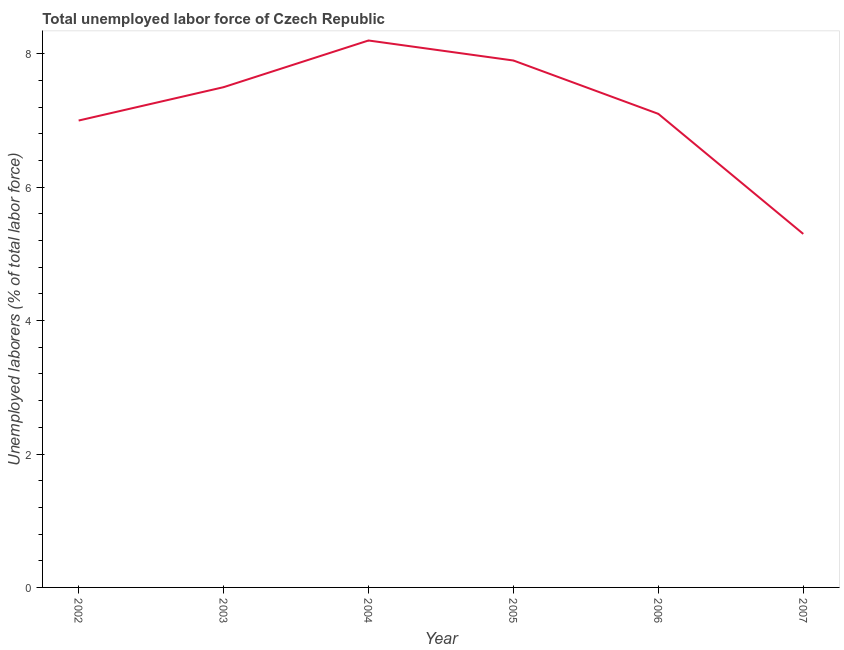Across all years, what is the maximum total unemployed labour force?
Ensure brevity in your answer.  8.2. Across all years, what is the minimum total unemployed labour force?
Make the answer very short. 5.3. In which year was the total unemployed labour force maximum?
Keep it short and to the point. 2004. In which year was the total unemployed labour force minimum?
Your answer should be very brief. 2007. What is the sum of the total unemployed labour force?
Your answer should be very brief. 43. What is the difference between the total unemployed labour force in 2004 and 2005?
Provide a short and direct response. 0.3. What is the average total unemployed labour force per year?
Your answer should be very brief. 7.17. What is the median total unemployed labour force?
Your answer should be compact. 7.3. In how many years, is the total unemployed labour force greater than 6.4 %?
Give a very brief answer. 5. Do a majority of the years between 2004 and 2003 (inclusive) have total unemployed labour force greater than 1.6 %?
Offer a very short reply. No. What is the ratio of the total unemployed labour force in 2002 to that in 2005?
Offer a very short reply. 0.89. Is the difference between the total unemployed labour force in 2004 and 2006 greater than the difference between any two years?
Your response must be concise. No. What is the difference between the highest and the second highest total unemployed labour force?
Your response must be concise. 0.3. Is the sum of the total unemployed labour force in 2002 and 2007 greater than the maximum total unemployed labour force across all years?
Offer a terse response. Yes. What is the difference between the highest and the lowest total unemployed labour force?
Your response must be concise. 2.9. In how many years, is the total unemployed labour force greater than the average total unemployed labour force taken over all years?
Offer a terse response. 3. Does the total unemployed labour force monotonically increase over the years?
Give a very brief answer. No. Does the graph contain any zero values?
Your answer should be compact. No. Does the graph contain grids?
Provide a succinct answer. No. What is the title of the graph?
Offer a terse response. Total unemployed labor force of Czech Republic. What is the label or title of the Y-axis?
Provide a short and direct response. Unemployed laborers (% of total labor force). What is the Unemployed laborers (% of total labor force) in 2004?
Your response must be concise. 8.2. What is the Unemployed laborers (% of total labor force) in 2005?
Your answer should be compact. 7.9. What is the Unemployed laborers (% of total labor force) in 2006?
Offer a terse response. 7.1. What is the Unemployed laborers (% of total labor force) in 2007?
Give a very brief answer. 5.3. What is the difference between the Unemployed laborers (% of total labor force) in 2002 and 2003?
Your response must be concise. -0.5. What is the difference between the Unemployed laborers (% of total labor force) in 2002 and 2005?
Offer a very short reply. -0.9. What is the difference between the Unemployed laborers (% of total labor force) in 2002 and 2007?
Keep it short and to the point. 1.7. What is the difference between the Unemployed laborers (% of total labor force) in 2004 and 2005?
Provide a short and direct response. 0.3. What is the difference between the Unemployed laborers (% of total labor force) in 2004 and 2007?
Provide a short and direct response. 2.9. What is the difference between the Unemployed laborers (% of total labor force) in 2006 and 2007?
Offer a terse response. 1.8. What is the ratio of the Unemployed laborers (% of total labor force) in 2002 to that in 2003?
Your answer should be compact. 0.93. What is the ratio of the Unemployed laborers (% of total labor force) in 2002 to that in 2004?
Your response must be concise. 0.85. What is the ratio of the Unemployed laborers (% of total labor force) in 2002 to that in 2005?
Offer a very short reply. 0.89. What is the ratio of the Unemployed laborers (% of total labor force) in 2002 to that in 2007?
Keep it short and to the point. 1.32. What is the ratio of the Unemployed laborers (% of total labor force) in 2003 to that in 2004?
Ensure brevity in your answer.  0.92. What is the ratio of the Unemployed laborers (% of total labor force) in 2003 to that in 2005?
Your response must be concise. 0.95. What is the ratio of the Unemployed laborers (% of total labor force) in 2003 to that in 2006?
Your response must be concise. 1.06. What is the ratio of the Unemployed laborers (% of total labor force) in 2003 to that in 2007?
Your answer should be compact. 1.42. What is the ratio of the Unemployed laborers (% of total labor force) in 2004 to that in 2005?
Your answer should be compact. 1.04. What is the ratio of the Unemployed laborers (% of total labor force) in 2004 to that in 2006?
Keep it short and to the point. 1.16. What is the ratio of the Unemployed laborers (% of total labor force) in 2004 to that in 2007?
Keep it short and to the point. 1.55. What is the ratio of the Unemployed laborers (% of total labor force) in 2005 to that in 2006?
Make the answer very short. 1.11. What is the ratio of the Unemployed laborers (% of total labor force) in 2005 to that in 2007?
Give a very brief answer. 1.49. What is the ratio of the Unemployed laborers (% of total labor force) in 2006 to that in 2007?
Offer a very short reply. 1.34. 